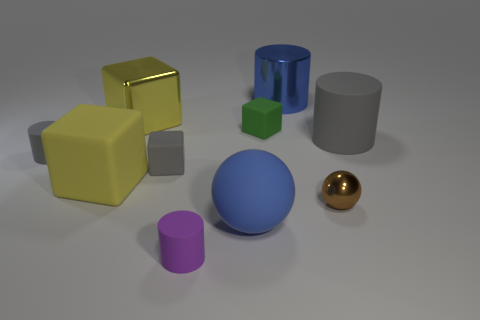There is a rubber cylinder that is to the left of the large blue ball and behind the blue sphere; what size is it?
Your response must be concise. Small. What material is the gray cylinder that is the same size as the purple matte cylinder?
Your response must be concise. Rubber. There is a blue metallic cylinder behind the blue thing that is in front of the small brown metal thing; how many big blue shiny things are to the right of it?
Provide a short and direct response. 0. Is the color of the small rubber object that is to the left of the yellow rubber block the same as the small cube on the left side of the purple rubber cylinder?
Your answer should be very brief. Yes. The rubber cylinder that is behind the small brown ball and to the left of the brown shiny thing is what color?
Your response must be concise. Gray. What number of yellow metal cubes are the same size as the shiny ball?
Keep it short and to the point. 0. There is a shiny thing that is on the left side of the blue thing in front of the big blue cylinder; what shape is it?
Offer a terse response. Cube. What shape is the large blue thing left of the big cylinder that is behind the matte cylinder that is right of the big blue cylinder?
Ensure brevity in your answer.  Sphere. How many matte things have the same shape as the blue metal thing?
Provide a succinct answer. 3. How many green matte cubes are left of the gray cylinder right of the big blue metallic object?
Offer a terse response. 1. 